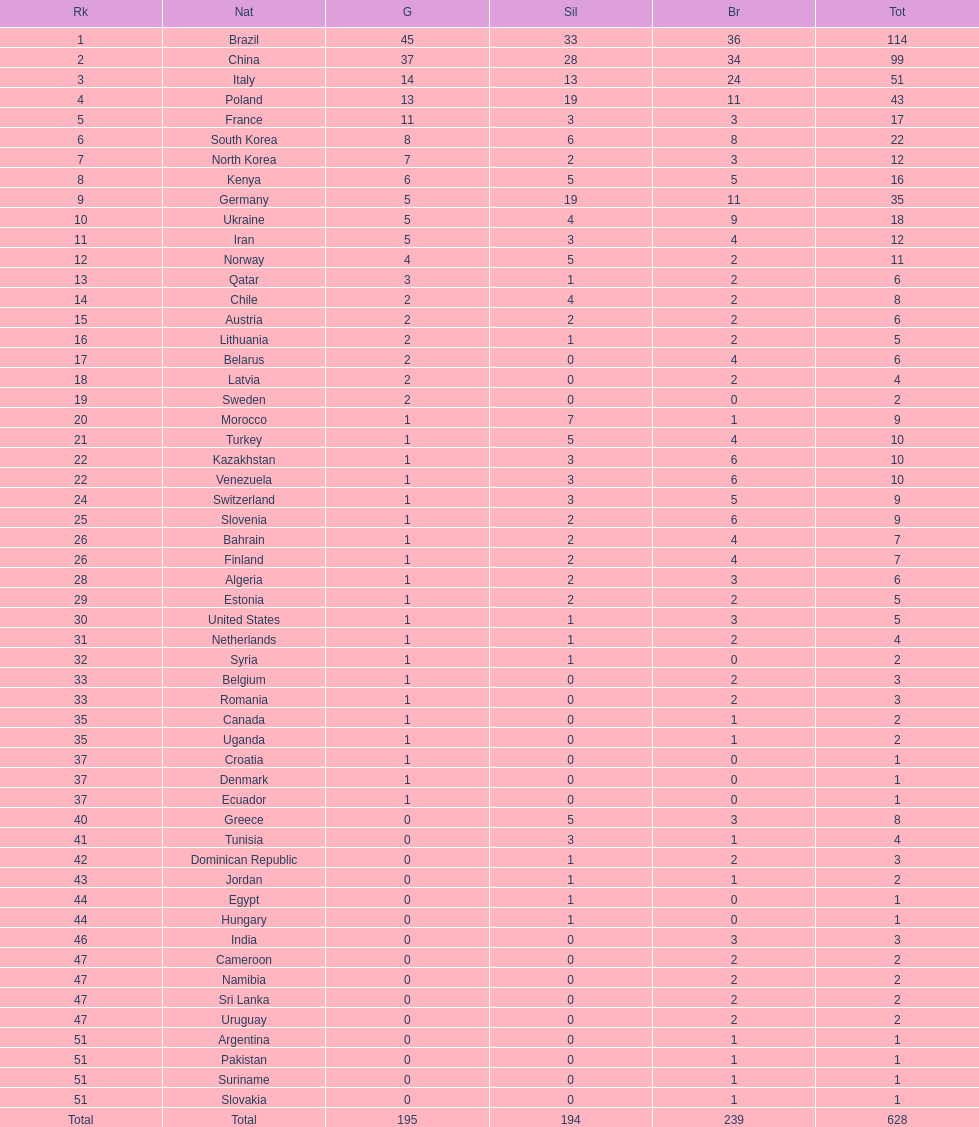How many more gold medals does china have over france? 26. 